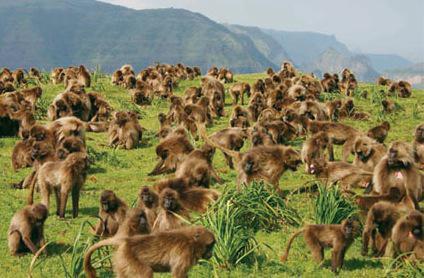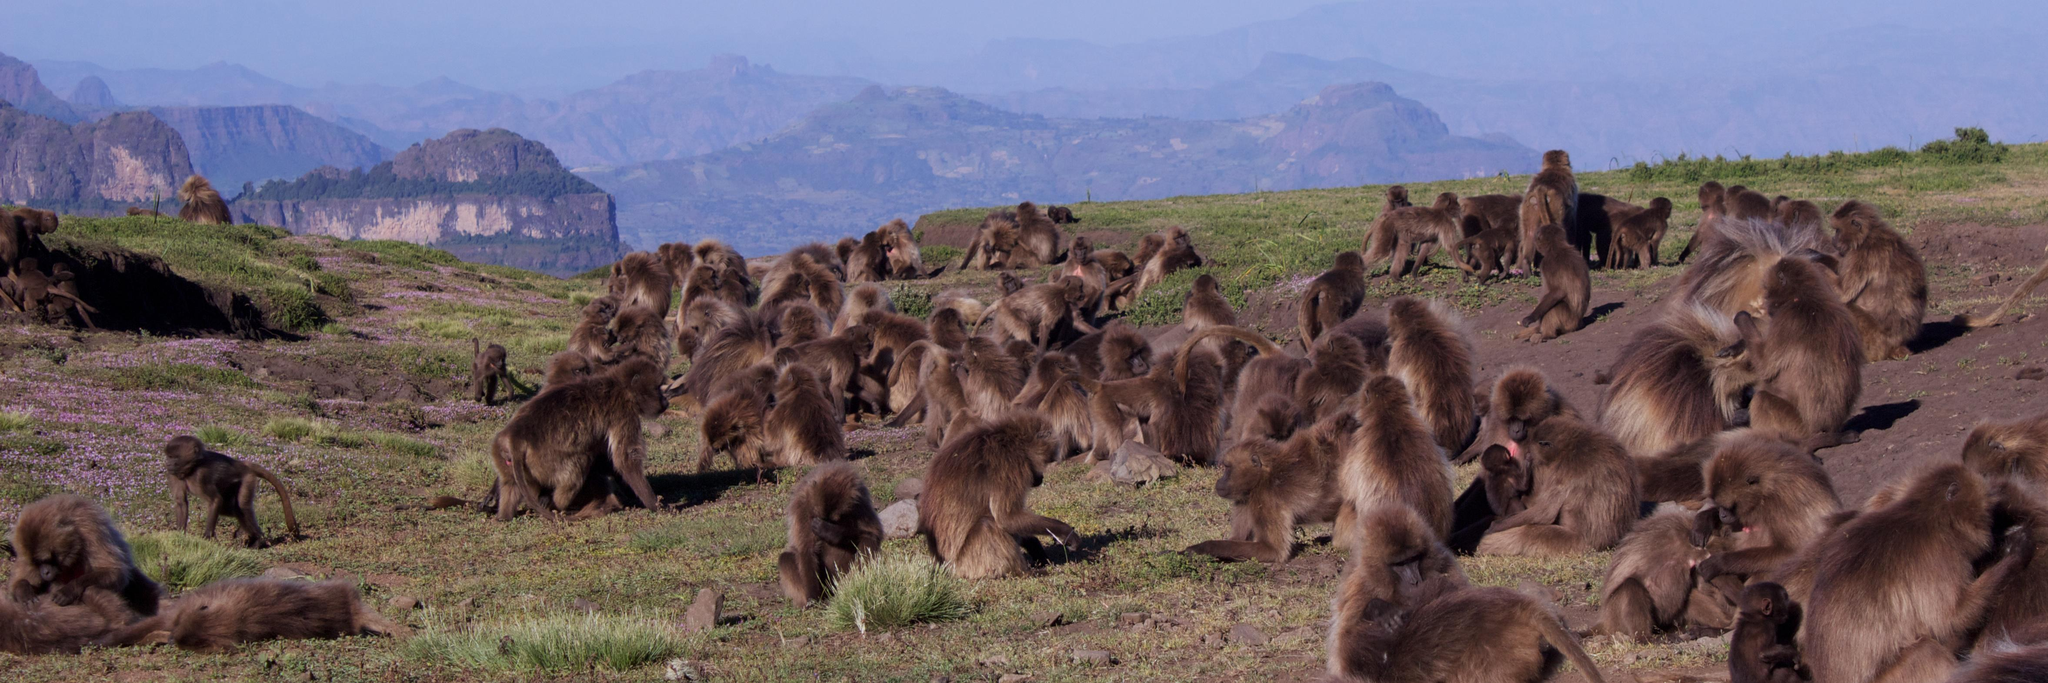The first image is the image on the left, the second image is the image on the right. Analyze the images presented: Is the assertion "All images feature monkeys sitting on grass." valid? Answer yes or no. Yes. The first image is the image on the left, the second image is the image on the right. Examine the images to the left and right. Is the description "An image shows baboons sitting in a green valley with many visible trees on the hillside behind them." accurate? Answer yes or no. No. 